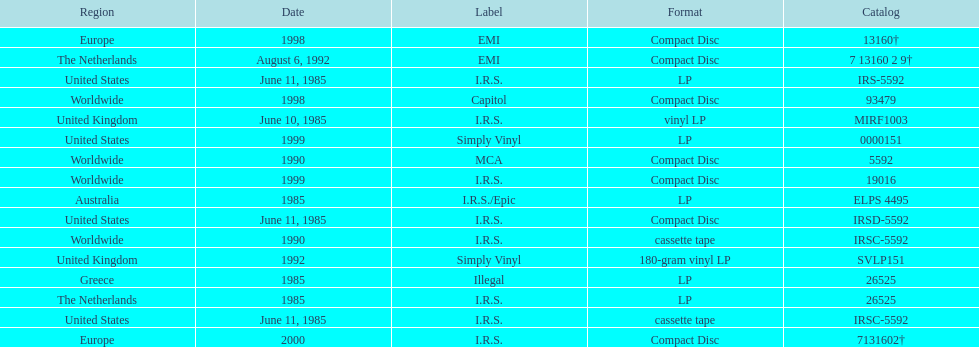Parse the full table. {'header': ['Region', 'Date', 'Label', 'Format', 'Catalog'], 'rows': [['Europe', '1998', 'EMI', 'Compact Disc', '13160†'], ['The Netherlands', 'August 6, 1992', 'EMI', 'Compact Disc', '7 13160 2 9†'], ['United States', 'June 11, 1985', 'I.R.S.', 'LP', 'IRS-5592'], ['Worldwide', '1998', 'Capitol', 'Compact Disc', '93479'], ['United Kingdom', 'June 10, 1985', 'I.R.S.', 'vinyl LP', 'MIRF1003'], ['United States', '1999', 'Simply Vinyl', 'LP', '0000151'], ['Worldwide', '1990', 'MCA', 'Compact Disc', '5592'], ['Worldwide', '1999', 'I.R.S.', 'Compact Disc', '19016'], ['Australia', '1985', 'I.R.S./Epic', 'LP', 'ELPS 4495'], ['United States', 'June 11, 1985', 'I.R.S.', 'Compact Disc', 'IRSD-5592'], ['Worldwide', '1990', 'I.R.S.', 'cassette tape', 'IRSC-5592'], ['United Kingdom', '1992', 'Simply Vinyl', '180-gram vinyl LP', 'SVLP151'], ['Greece', '1985', 'Illegal', 'LP', '26525'], ['The Netherlands', '1985', 'I.R.S.', 'LP', '26525'], ['United States', 'June 11, 1985', 'I.R.S.', 'cassette tape', 'IRSC-5592'], ['Europe', '2000', 'I.R.S.', 'Compact Disc', '7131602†']]} Which country or region had the most releases? Worldwide. 